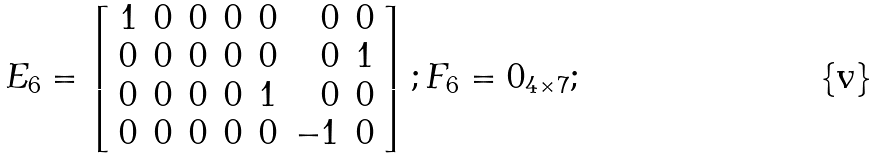Convert formula to latex. <formula><loc_0><loc_0><loc_500><loc_500>E _ { 6 } = \left [ \begin{array} { r r r r r r r r } 1 & 0 & 0 & 0 & 0 & 0 & 0 \\ 0 & 0 & 0 & 0 & 0 & 0 & 1 \\ 0 & 0 & 0 & 0 & 1 & 0 & 0 \\ 0 & 0 & 0 & 0 & 0 & - 1 & 0 \\ \end{array} \right ] ; F _ { 6 } = 0 _ { 4 \times 7 } ;</formula> 